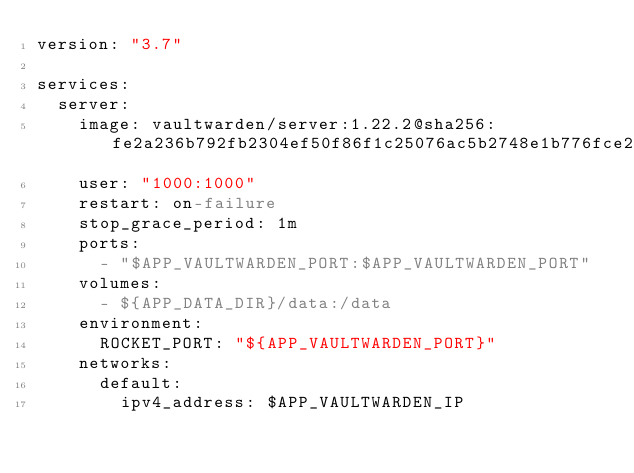<code> <loc_0><loc_0><loc_500><loc_500><_YAML_>version: "3.7"

services:
  server:
    image: vaultwarden/server:1.22.2@sha256:fe2a236b792fb2304ef50f86f1c25076ac5b2748e1b776fce260ad12ad29188d
    user: "1000:1000"
    restart: on-failure
    stop_grace_period: 1m
    ports:
      - "$APP_VAULTWARDEN_PORT:$APP_VAULTWARDEN_PORT"
    volumes:
      - ${APP_DATA_DIR}/data:/data
    environment:
      ROCKET_PORT: "${APP_VAULTWARDEN_PORT}"
    networks:
      default:
        ipv4_address: $APP_VAULTWARDEN_IP
</code> 